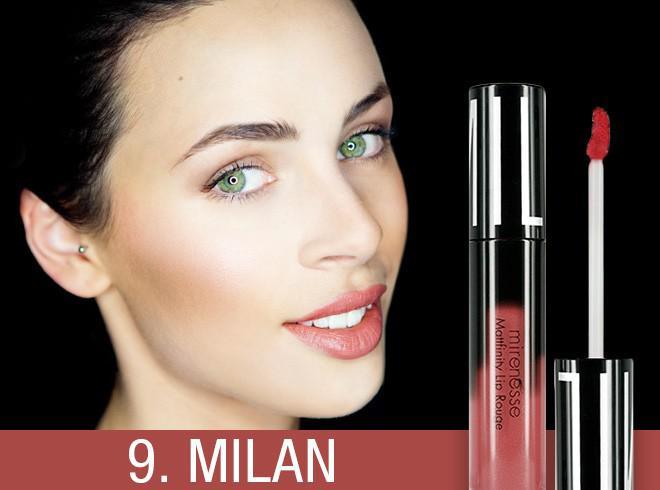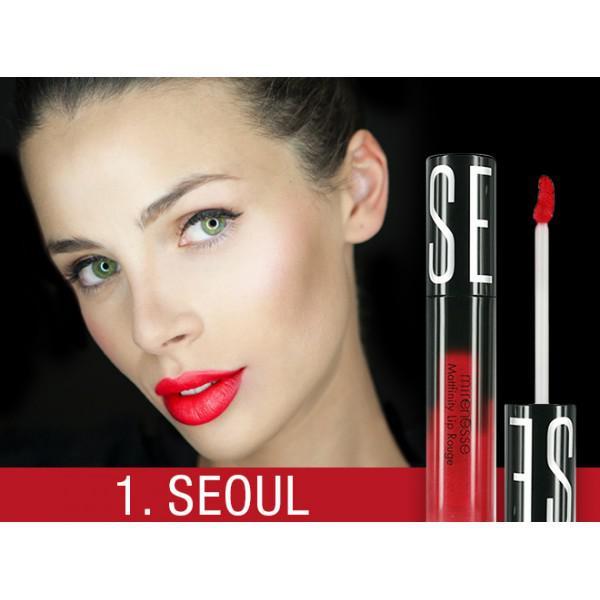The first image is the image on the left, the second image is the image on the right. For the images shown, is this caption "There are no tinted lips in the left image only." true? Answer yes or no. No. 